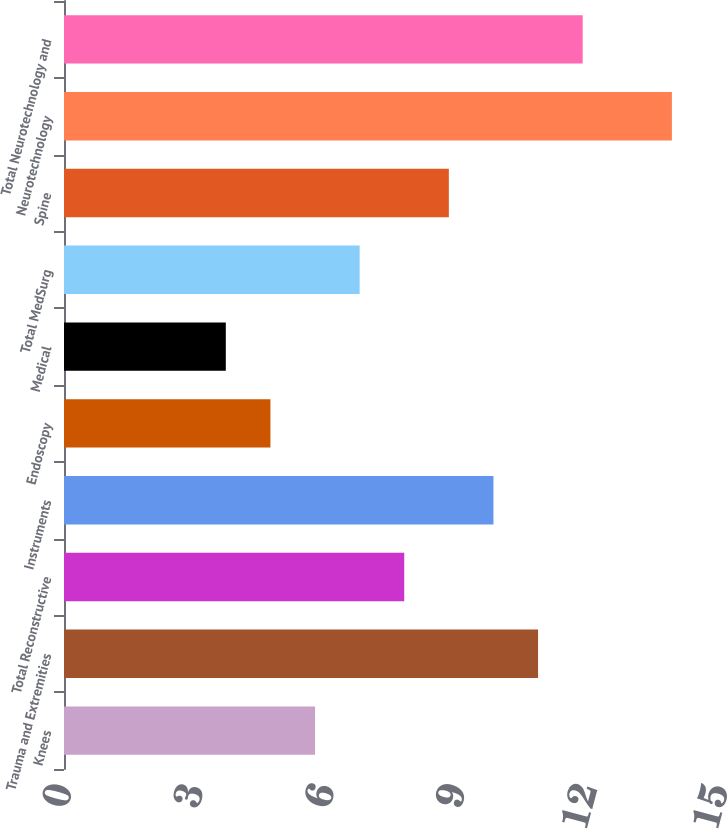Convert chart to OTSL. <chart><loc_0><loc_0><loc_500><loc_500><bar_chart><fcel>Knees<fcel>Trauma and Extremities<fcel>Total Reconstructive<fcel>Instruments<fcel>Endoscopy<fcel>Medical<fcel>Total MedSurg<fcel>Spine<fcel>Neurotechnology<fcel>Total Neurotechnology and<nl><fcel>5.74<fcel>10.84<fcel>7.78<fcel>9.82<fcel>4.72<fcel>3.7<fcel>6.76<fcel>8.8<fcel>13.9<fcel>11.86<nl></chart> 